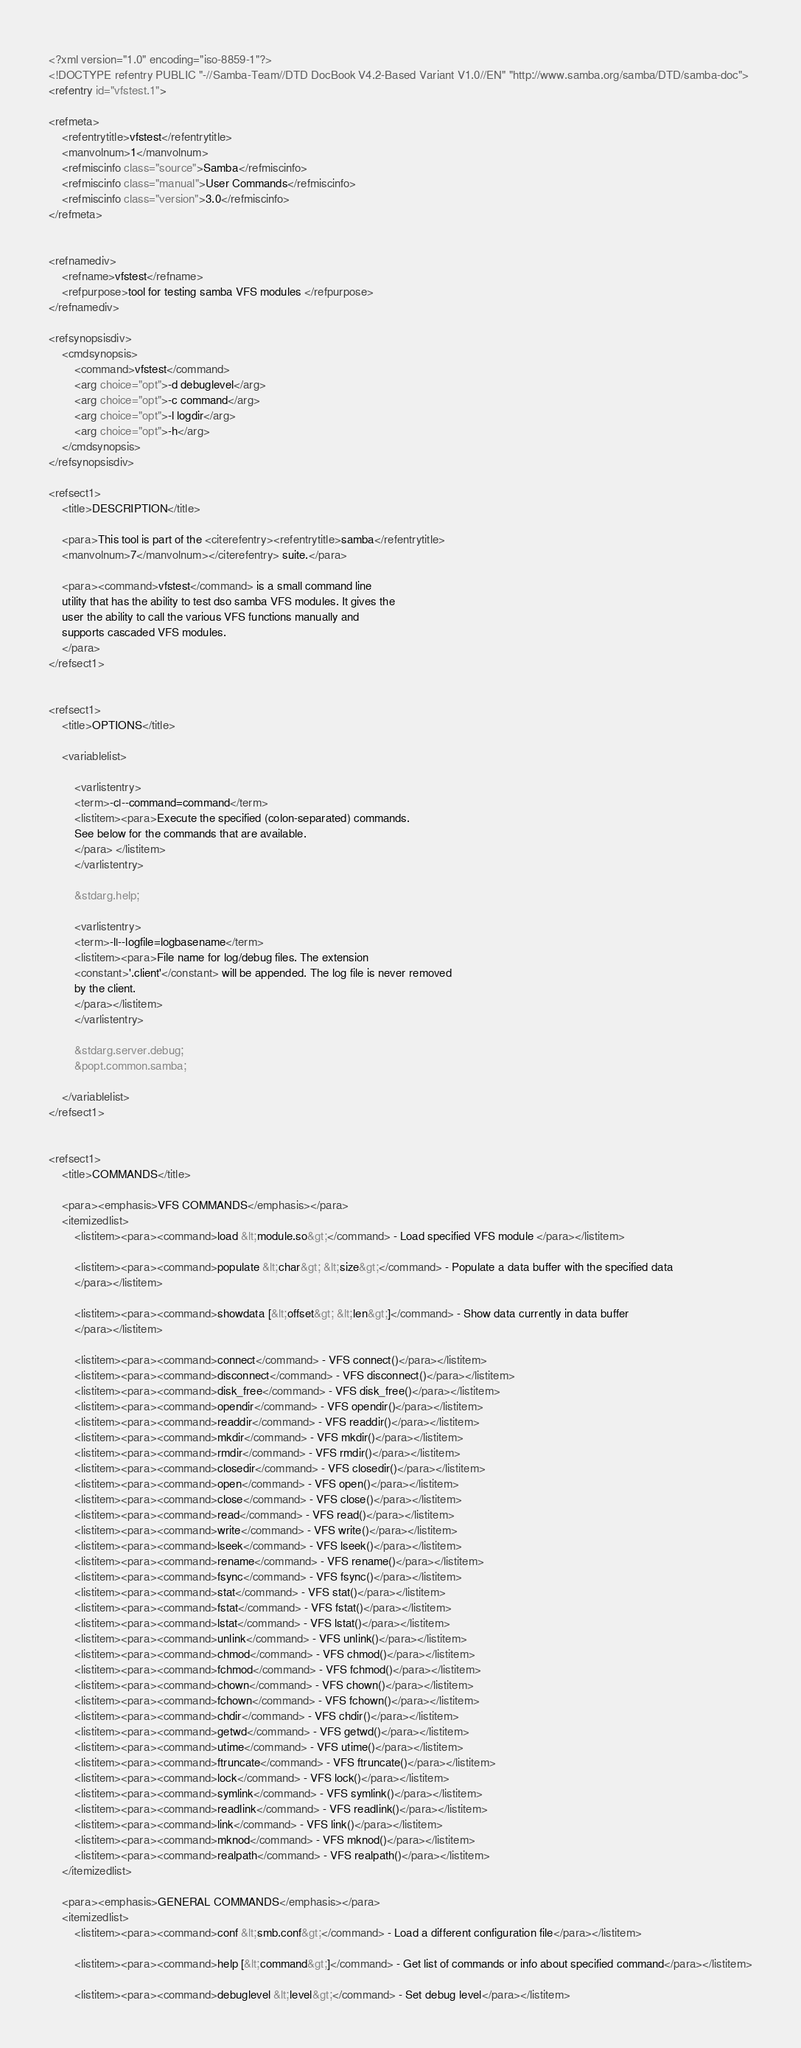<code> <loc_0><loc_0><loc_500><loc_500><_XML_><?xml version="1.0" encoding="iso-8859-1"?>
<!DOCTYPE refentry PUBLIC "-//Samba-Team//DTD DocBook V4.2-Based Variant V1.0//EN" "http://www.samba.org/samba/DTD/samba-doc">
<refentry id="vfstest.1">

<refmeta>
	<refentrytitle>vfstest</refentrytitle>
	<manvolnum>1</manvolnum>
	<refmiscinfo class="source">Samba</refmiscinfo>
	<refmiscinfo class="manual">User Commands</refmiscinfo>
	<refmiscinfo class="version">3.0</refmiscinfo>
</refmeta>


<refnamediv>
	<refname>vfstest</refname>
	<refpurpose>tool for testing samba VFS modules </refpurpose>
</refnamediv>

<refsynopsisdiv>
	<cmdsynopsis>
		<command>vfstest</command>
		<arg choice="opt">-d debuglevel</arg>
		<arg choice="opt">-c command</arg>
		<arg choice="opt">-l logdir</arg>
		<arg choice="opt">-h</arg>
	</cmdsynopsis>
</refsynopsisdiv>

<refsect1>
	<title>DESCRIPTION</title>

	<para>This tool is part of the <citerefentry><refentrytitle>samba</refentrytitle>
	<manvolnum>7</manvolnum></citerefentry> suite.</para>

	<para><command>vfstest</command> is a small command line
	utility that has the ability to test dso samba VFS modules. It gives the
	user the ability to call the various VFS functions manually and
	supports cascaded VFS modules.
	</para>
</refsect1>


<refsect1>
	<title>OPTIONS</title>

	<variablelist>

		<varlistentry>
		<term>-c|--command=command</term>
		<listitem><para>Execute the specified (colon-separated) commands.
		See below for the commands that are available.
		</para> </listitem>
		</varlistentry>

		&stdarg.help;

		<varlistentry>
		<term>-l|--logfile=logbasename</term>
		<listitem><para>File name for log/debug files. The extension
		<constant>'.client'</constant> will be appended. The log file is never removed
		by the client.
		</para></listitem>
		</varlistentry>

		&stdarg.server.debug;
		&popt.common.samba;

	</variablelist>
</refsect1>


<refsect1>
	<title>COMMANDS</title>

	<para><emphasis>VFS COMMANDS</emphasis></para>
	<itemizedlist>
		<listitem><para><command>load &lt;module.so&gt;</command> - Load specified VFS module </para></listitem>

		<listitem><para><command>populate &lt;char&gt; &lt;size&gt;</command> - Populate a data buffer with the specified data
		</para></listitem>

		<listitem><para><command>showdata [&lt;offset&gt; &lt;len&gt;]</command> - Show data currently in data buffer
		</para></listitem>

		<listitem><para><command>connect</command> - VFS connect()</para></listitem>
		<listitem><para><command>disconnect</command> - VFS disconnect()</para></listitem>
		<listitem><para><command>disk_free</command> - VFS disk_free()</para></listitem>
		<listitem><para><command>opendir</command> - VFS opendir()</para></listitem>
		<listitem><para><command>readdir</command> - VFS readdir()</para></listitem>
		<listitem><para><command>mkdir</command> - VFS mkdir()</para></listitem>
		<listitem><para><command>rmdir</command> - VFS rmdir()</para></listitem>
		<listitem><para><command>closedir</command> - VFS closedir()</para></listitem>
		<listitem><para><command>open</command> - VFS open()</para></listitem>
		<listitem><para><command>close</command> - VFS close()</para></listitem>
		<listitem><para><command>read</command> - VFS read()</para></listitem>
		<listitem><para><command>write</command> - VFS write()</para></listitem>
		<listitem><para><command>lseek</command> - VFS lseek()</para></listitem>
		<listitem><para><command>rename</command> - VFS rename()</para></listitem>
		<listitem><para><command>fsync</command> - VFS fsync()</para></listitem>
		<listitem><para><command>stat</command> - VFS stat()</para></listitem>
		<listitem><para><command>fstat</command> - VFS fstat()</para></listitem>
		<listitem><para><command>lstat</command> - VFS lstat()</para></listitem>
		<listitem><para><command>unlink</command> - VFS unlink()</para></listitem>
		<listitem><para><command>chmod</command> - VFS chmod()</para></listitem>
		<listitem><para><command>fchmod</command> - VFS fchmod()</para></listitem>
		<listitem><para><command>chown</command> - VFS chown()</para></listitem>
		<listitem><para><command>fchown</command> - VFS fchown()</para></listitem>
		<listitem><para><command>chdir</command> - VFS chdir()</para></listitem>
		<listitem><para><command>getwd</command> - VFS getwd()</para></listitem>
		<listitem><para><command>utime</command> - VFS utime()</para></listitem>
		<listitem><para><command>ftruncate</command> - VFS ftruncate()</para></listitem>
		<listitem><para><command>lock</command> - VFS lock()</para></listitem>
		<listitem><para><command>symlink</command> - VFS symlink()</para></listitem>
		<listitem><para><command>readlink</command> - VFS readlink()</para></listitem>
		<listitem><para><command>link</command> - VFS link()</para></listitem>
		<listitem><para><command>mknod</command> - VFS mknod()</para></listitem>
		<listitem><para><command>realpath</command> - VFS realpath()</para></listitem>
	</itemizedlist>

	<para><emphasis>GENERAL COMMANDS</emphasis></para>
	<itemizedlist>
		<listitem><para><command>conf &lt;smb.conf&gt;</command> - Load a different configuration file</para></listitem>

		<listitem><para><command>help [&lt;command&gt;]</command> - Get list of commands or info about specified command</para></listitem>

		<listitem><para><command>debuglevel &lt;level&gt;</command> - Set debug level</para></listitem>
</code> 